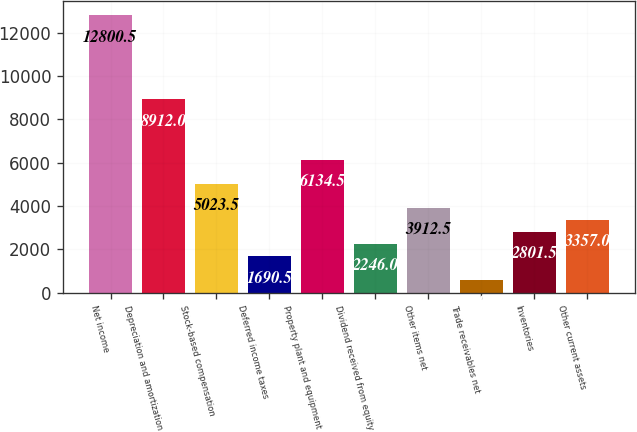Convert chart. <chart><loc_0><loc_0><loc_500><loc_500><bar_chart><fcel>Net income<fcel>Depreciation and amortization<fcel>Stock-based compensation<fcel>Deferred income taxes<fcel>Property plant and equipment<fcel>Dividend received from equity<fcel>Other items net<fcel>Trade receivables net<fcel>Inventories<fcel>Other current assets<nl><fcel>12800.5<fcel>8912<fcel>5023.5<fcel>1690.5<fcel>6134.5<fcel>2246<fcel>3912.5<fcel>579.5<fcel>2801.5<fcel>3357<nl></chart> 